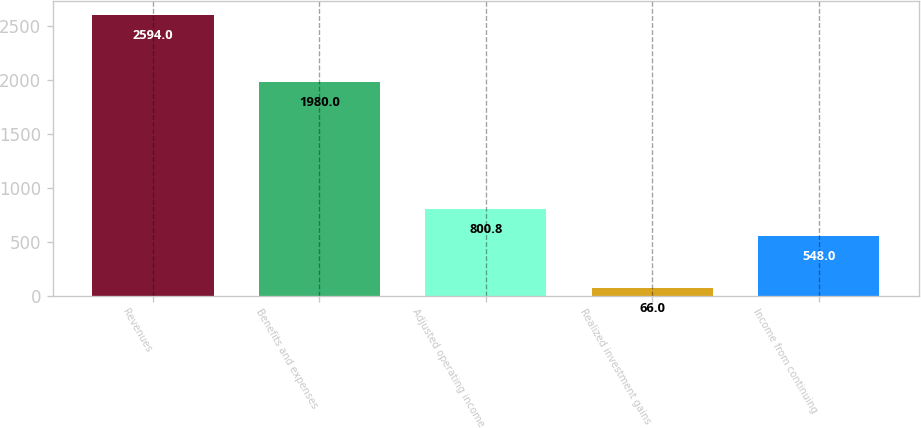Convert chart. <chart><loc_0><loc_0><loc_500><loc_500><bar_chart><fcel>Revenues<fcel>Benefits and expenses<fcel>Adjusted operating income<fcel>Realized investment gains<fcel>Income from continuing<nl><fcel>2594<fcel>1980<fcel>800.8<fcel>66<fcel>548<nl></chart> 